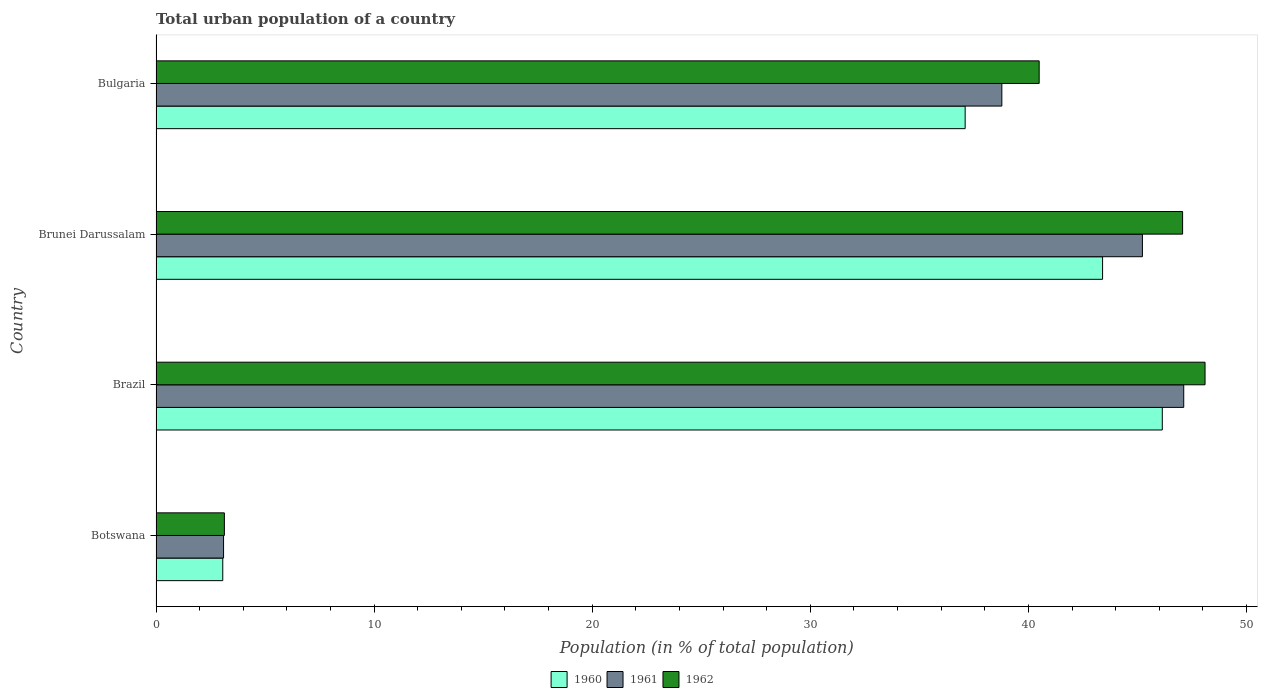How many bars are there on the 2nd tick from the bottom?
Keep it short and to the point. 3. What is the label of the 4th group of bars from the top?
Ensure brevity in your answer.  Botswana. In how many cases, is the number of bars for a given country not equal to the number of legend labels?
Offer a terse response. 0. What is the urban population in 1961 in Botswana?
Keep it short and to the point. 3.1. Across all countries, what is the maximum urban population in 1960?
Make the answer very short. 46.14. Across all countries, what is the minimum urban population in 1961?
Offer a terse response. 3.1. In which country was the urban population in 1960 maximum?
Give a very brief answer. Brazil. In which country was the urban population in 1960 minimum?
Your answer should be very brief. Botswana. What is the total urban population in 1961 in the graph?
Make the answer very short. 134.23. What is the difference between the urban population in 1960 in Brazil and that in Brunei Darussalam?
Your answer should be very brief. 2.74. What is the difference between the urban population in 1961 in Brazil and the urban population in 1960 in Bulgaria?
Keep it short and to the point. 10.02. What is the average urban population in 1960 per country?
Make the answer very short. 32.43. What is the difference between the urban population in 1962 and urban population in 1961 in Brazil?
Provide a succinct answer. 0.98. What is the ratio of the urban population in 1960 in Botswana to that in Brazil?
Provide a short and direct response. 0.07. Is the urban population in 1962 in Botswana less than that in Bulgaria?
Your answer should be very brief. Yes. What is the difference between the highest and the second highest urban population in 1960?
Your response must be concise. 2.74. What is the difference between the highest and the lowest urban population in 1962?
Offer a very short reply. 44.96. Is the sum of the urban population in 1961 in Brunei Darussalam and Bulgaria greater than the maximum urban population in 1962 across all countries?
Make the answer very short. Yes. What does the 3rd bar from the top in Brazil represents?
Provide a short and direct response. 1960. What does the 1st bar from the bottom in Brazil represents?
Your answer should be very brief. 1960. Is it the case that in every country, the sum of the urban population in 1960 and urban population in 1961 is greater than the urban population in 1962?
Your response must be concise. Yes. How many countries are there in the graph?
Your response must be concise. 4. What is the difference between two consecutive major ticks on the X-axis?
Ensure brevity in your answer.  10. Where does the legend appear in the graph?
Offer a very short reply. Bottom center. How many legend labels are there?
Keep it short and to the point. 3. How are the legend labels stacked?
Your response must be concise. Horizontal. What is the title of the graph?
Your answer should be compact. Total urban population of a country. Does "2012" appear as one of the legend labels in the graph?
Your answer should be very brief. No. What is the label or title of the X-axis?
Your answer should be very brief. Population (in % of total population). What is the label or title of the Y-axis?
Provide a short and direct response. Country. What is the Population (in % of total population) of 1960 in Botswana?
Make the answer very short. 3.06. What is the Population (in % of total population) in 1961 in Botswana?
Your response must be concise. 3.1. What is the Population (in % of total population) of 1962 in Botswana?
Ensure brevity in your answer.  3.13. What is the Population (in % of total population) in 1960 in Brazil?
Offer a terse response. 46.14. What is the Population (in % of total population) in 1961 in Brazil?
Give a very brief answer. 47.12. What is the Population (in % of total population) of 1962 in Brazil?
Keep it short and to the point. 48.1. What is the Population (in % of total population) in 1960 in Brunei Darussalam?
Provide a short and direct response. 43.4. What is the Population (in % of total population) in 1961 in Brunei Darussalam?
Provide a succinct answer. 45.23. What is the Population (in % of total population) of 1962 in Brunei Darussalam?
Give a very brief answer. 47.07. What is the Population (in % of total population) of 1960 in Bulgaria?
Offer a very short reply. 37.1. What is the Population (in % of total population) of 1961 in Bulgaria?
Offer a terse response. 38.78. What is the Population (in % of total population) of 1962 in Bulgaria?
Your answer should be very brief. 40.49. Across all countries, what is the maximum Population (in % of total population) of 1960?
Your answer should be very brief. 46.14. Across all countries, what is the maximum Population (in % of total population) of 1961?
Give a very brief answer. 47.12. Across all countries, what is the maximum Population (in % of total population) of 1962?
Keep it short and to the point. 48.1. Across all countries, what is the minimum Population (in % of total population) in 1960?
Ensure brevity in your answer.  3.06. Across all countries, what is the minimum Population (in % of total population) in 1961?
Your answer should be very brief. 3.1. Across all countries, what is the minimum Population (in % of total population) in 1962?
Provide a short and direct response. 3.13. What is the total Population (in % of total population) in 1960 in the graph?
Your answer should be compact. 129.7. What is the total Population (in % of total population) in 1961 in the graph?
Your answer should be compact. 134.23. What is the total Population (in % of total population) in 1962 in the graph?
Provide a succinct answer. 138.8. What is the difference between the Population (in % of total population) of 1960 in Botswana and that in Brazil?
Make the answer very short. -43.08. What is the difference between the Population (in % of total population) in 1961 in Botswana and that in Brazil?
Your answer should be very brief. -44.02. What is the difference between the Population (in % of total population) of 1962 in Botswana and that in Brazil?
Offer a very short reply. -44.97. What is the difference between the Population (in % of total population) of 1960 in Botswana and that in Brunei Darussalam?
Your answer should be very brief. -40.34. What is the difference between the Population (in % of total population) of 1961 in Botswana and that in Brunei Darussalam?
Provide a succinct answer. -42.13. What is the difference between the Population (in % of total population) in 1962 in Botswana and that in Brunei Darussalam?
Provide a short and direct response. -43.94. What is the difference between the Population (in % of total population) in 1960 in Botswana and that in Bulgaria?
Your answer should be very brief. -34.04. What is the difference between the Population (in % of total population) in 1961 in Botswana and that in Bulgaria?
Keep it short and to the point. -35.69. What is the difference between the Population (in % of total population) in 1962 in Botswana and that in Bulgaria?
Offer a terse response. -37.36. What is the difference between the Population (in % of total population) in 1960 in Brazil and that in Brunei Darussalam?
Offer a terse response. 2.74. What is the difference between the Population (in % of total population) in 1961 in Brazil and that in Brunei Darussalam?
Give a very brief answer. 1.89. What is the difference between the Population (in % of total population) in 1960 in Brazil and that in Bulgaria?
Offer a very short reply. 9.04. What is the difference between the Population (in % of total population) of 1961 in Brazil and that in Bulgaria?
Offer a very short reply. 8.34. What is the difference between the Population (in % of total population) in 1962 in Brazil and that in Bulgaria?
Your answer should be very brief. 7.61. What is the difference between the Population (in % of total population) in 1960 in Brunei Darussalam and that in Bulgaria?
Keep it short and to the point. 6.3. What is the difference between the Population (in % of total population) of 1961 in Brunei Darussalam and that in Bulgaria?
Ensure brevity in your answer.  6.45. What is the difference between the Population (in % of total population) in 1962 in Brunei Darussalam and that in Bulgaria?
Ensure brevity in your answer.  6.58. What is the difference between the Population (in % of total population) in 1960 in Botswana and the Population (in % of total population) in 1961 in Brazil?
Make the answer very short. -44.06. What is the difference between the Population (in % of total population) of 1960 in Botswana and the Population (in % of total population) of 1962 in Brazil?
Make the answer very short. -45.04. What is the difference between the Population (in % of total population) of 1961 in Botswana and the Population (in % of total population) of 1962 in Brazil?
Your answer should be very brief. -45. What is the difference between the Population (in % of total population) in 1960 in Botswana and the Population (in % of total population) in 1961 in Brunei Darussalam?
Your answer should be compact. -42.17. What is the difference between the Population (in % of total population) in 1960 in Botswana and the Population (in % of total population) in 1962 in Brunei Darussalam?
Your answer should be compact. -44.01. What is the difference between the Population (in % of total population) of 1961 in Botswana and the Population (in % of total population) of 1962 in Brunei Darussalam?
Your response must be concise. -43.97. What is the difference between the Population (in % of total population) of 1960 in Botswana and the Population (in % of total population) of 1961 in Bulgaria?
Offer a very short reply. -35.72. What is the difference between the Population (in % of total population) of 1960 in Botswana and the Population (in % of total population) of 1962 in Bulgaria?
Keep it short and to the point. -37.43. What is the difference between the Population (in % of total population) in 1961 in Botswana and the Population (in % of total population) in 1962 in Bulgaria?
Your response must be concise. -37.4. What is the difference between the Population (in % of total population) of 1960 in Brazil and the Population (in % of total population) of 1961 in Brunei Darussalam?
Provide a succinct answer. 0.91. What is the difference between the Population (in % of total population) in 1960 in Brazil and the Population (in % of total population) in 1962 in Brunei Darussalam?
Provide a succinct answer. -0.93. What is the difference between the Population (in % of total population) of 1961 in Brazil and the Population (in % of total population) of 1962 in Brunei Darussalam?
Your answer should be very brief. 0.05. What is the difference between the Population (in % of total population) in 1960 in Brazil and the Population (in % of total population) in 1961 in Bulgaria?
Your response must be concise. 7.36. What is the difference between the Population (in % of total population) in 1960 in Brazil and the Population (in % of total population) in 1962 in Bulgaria?
Ensure brevity in your answer.  5.64. What is the difference between the Population (in % of total population) in 1961 in Brazil and the Population (in % of total population) in 1962 in Bulgaria?
Offer a very short reply. 6.63. What is the difference between the Population (in % of total population) of 1960 in Brunei Darussalam and the Population (in % of total population) of 1961 in Bulgaria?
Provide a short and direct response. 4.62. What is the difference between the Population (in % of total population) in 1960 in Brunei Darussalam and the Population (in % of total population) in 1962 in Bulgaria?
Provide a succinct answer. 2.91. What is the difference between the Population (in % of total population) of 1961 in Brunei Darussalam and the Population (in % of total population) of 1962 in Bulgaria?
Provide a short and direct response. 4.73. What is the average Population (in % of total population) of 1960 per country?
Provide a succinct answer. 32.42. What is the average Population (in % of total population) of 1961 per country?
Your answer should be very brief. 33.56. What is the average Population (in % of total population) of 1962 per country?
Your answer should be very brief. 34.7. What is the difference between the Population (in % of total population) of 1960 and Population (in % of total population) of 1961 in Botswana?
Offer a very short reply. -0.04. What is the difference between the Population (in % of total population) of 1960 and Population (in % of total population) of 1962 in Botswana?
Offer a very short reply. -0.07. What is the difference between the Population (in % of total population) of 1961 and Population (in % of total population) of 1962 in Botswana?
Offer a very short reply. -0.04. What is the difference between the Population (in % of total population) in 1960 and Population (in % of total population) in 1961 in Brazil?
Ensure brevity in your answer.  -0.98. What is the difference between the Population (in % of total population) of 1960 and Population (in % of total population) of 1962 in Brazil?
Your answer should be very brief. -1.96. What is the difference between the Population (in % of total population) of 1961 and Population (in % of total population) of 1962 in Brazil?
Your response must be concise. -0.98. What is the difference between the Population (in % of total population) in 1960 and Population (in % of total population) in 1961 in Brunei Darussalam?
Provide a succinct answer. -1.83. What is the difference between the Population (in % of total population) of 1960 and Population (in % of total population) of 1962 in Brunei Darussalam?
Provide a succinct answer. -3.67. What is the difference between the Population (in % of total population) in 1961 and Population (in % of total population) in 1962 in Brunei Darussalam?
Ensure brevity in your answer.  -1.84. What is the difference between the Population (in % of total population) in 1960 and Population (in % of total population) in 1961 in Bulgaria?
Give a very brief answer. -1.68. What is the difference between the Population (in % of total population) of 1960 and Population (in % of total population) of 1962 in Bulgaria?
Offer a very short reply. -3.39. What is the difference between the Population (in % of total population) of 1961 and Population (in % of total population) of 1962 in Bulgaria?
Your response must be concise. -1.71. What is the ratio of the Population (in % of total population) in 1960 in Botswana to that in Brazil?
Your answer should be compact. 0.07. What is the ratio of the Population (in % of total population) in 1961 in Botswana to that in Brazil?
Ensure brevity in your answer.  0.07. What is the ratio of the Population (in % of total population) in 1962 in Botswana to that in Brazil?
Provide a short and direct response. 0.07. What is the ratio of the Population (in % of total population) in 1960 in Botswana to that in Brunei Darussalam?
Offer a terse response. 0.07. What is the ratio of the Population (in % of total population) in 1961 in Botswana to that in Brunei Darussalam?
Your answer should be very brief. 0.07. What is the ratio of the Population (in % of total population) in 1962 in Botswana to that in Brunei Darussalam?
Your answer should be very brief. 0.07. What is the ratio of the Population (in % of total population) of 1960 in Botswana to that in Bulgaria?
Keep it short and to the point. 0.08. What is the ratio of the Population (in % of total population) of 1961 in Botswana to that in Bulgaria?
Make the answer very short. 0.08. What is the ratio of the Population (in % of total population) in 1962 in Botswana to that in Bulgaria?
Ensure brevity in your answer.  0.08. What is the ratio of the Population (in % of total population) of 1960 in Brazil to that in Brunei Darussalam?
Give a very brief answer. 1.06. What is the ratio of the Population (in % of total population) in 1961 in Brazil to that in Brunei Darussalam?
Give a very brief answer. 1.04. What is the ratio of the Population (in % of total population) in 1962 in Brazil to that in Brunei Darussalam?
Keep it short and to the point. 1.02. What is the ratio of the Population (in % of total population) of 1960 in Brazil to that in Bulgaria?
Give a very brief answer. 1.24. What is the ratio of the Population (in % of total population) in 1961 in Brazil to that in Bulgaria?
Keep it short and to the point. 1.22. What is the ratio of the Population (in % of total population) of 1962 in Brazil to that in Bulgaria?
Keep it short and to the point. 1.19. What is the ratio of the Population (in % of total population) of 1960 in Brunei Darussalam to that in Bulgaria?
Keep it short and to the point. 1.17. What is the ratio of the Population (in % of total population) of 1961 in Brunei Darussalam to that in Bulgaria?
Ensure brevity in your answer.  1.17. What is the ratio of the Population (in % of total population) of 1962 in Brunei Darussalam to that in Bulgaria?
Give a very brief answer. 1.16. What is the difference between the highest and the second highest Population (in % of total population) of 1960?
Offer a very short reply. 2.74. What is the difference between the highest and the second highest Population (in % of total population) of 1961?
Your answer should be compact. 1.89. What is the difference between the highest and the second highest Population (in % of total population) in 1962?
Your answer should be very brief. 1.03. What is the difference between the highest and the lowest Population (in % of total population) of 1960?
Your response must be concise. 43.08. What is the difference between the highest and the lowest Population (in % of total population) of 1961?
Offer a very short reply. 44.02. What is the difference between the highest and the lowest Population (in % of total population) of 1962?
Provide a short and direct response. 44.97. 